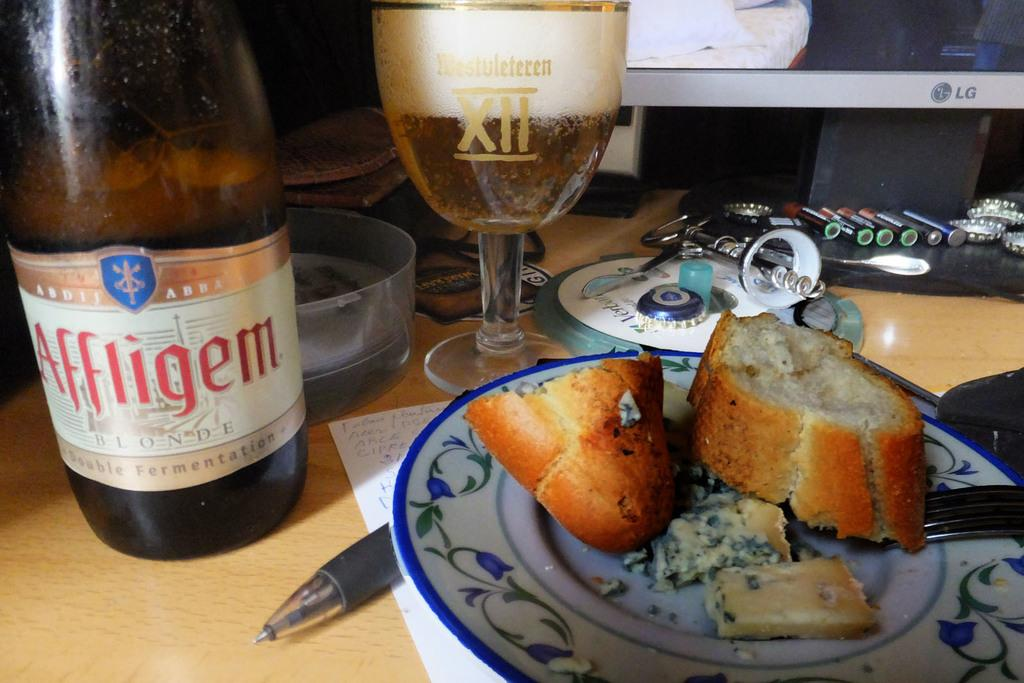<image>
Share a concise interpretation of the image provided. A bottle of Blonde german style beer sits next to a glass of beer and a plate with bread. 